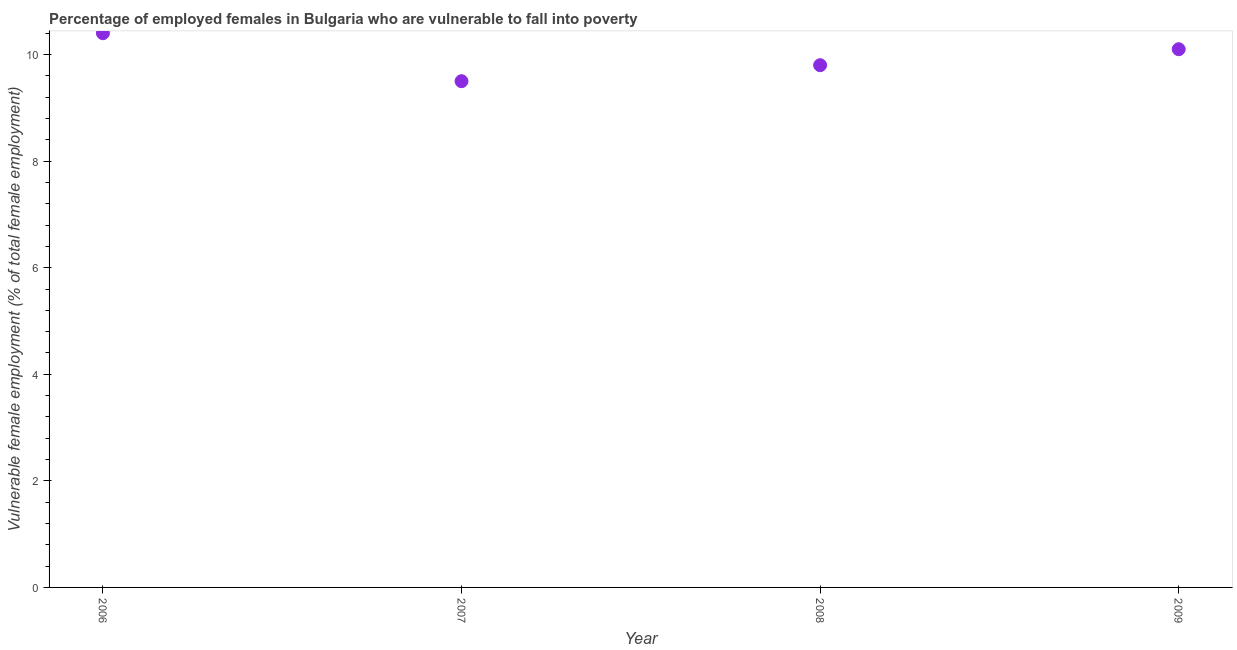What is the percentage of employed females who are vulnerable to fall into poverty in 2006?
Ensure brevity in your answer.  10.4. Across all years, what is the maximum percentage of employed females who are vulnerable to fall into poverty?
Your response must be concise. 10.4. Across all years, what is the minimum percentage of employed females who are vulnerable to fall into poverty?
Give a very brief answer. 9.5. In which year was the percentage of employed females who are vulnerable to fall into poverty minimum?
Provide a succinct answer. 2007. What is the sum of the percentage of employed females who are vulnerable to fall into poverty?
Your response must be concise. 39.8. What is the difference between the percentage of employed females who are vulnerable to fall into poverty in 2007 and 2008?
Ensure brevity in your answer.  -0.3. What is the average percentage of employed females who are vulnerable to fall into poverty per year?
Provide a short and direct response. 9.95. What is the median percentage of employed females who are vulnerable to fall into poverty?
Give a very brief answer. 9.95. In how many years, is the percentage of employed females who are vulnerable to fall into poverty greater than 0.8 %?
Ensure brevity in your answer.  4. Do a majority of the years between 2009 and 2007 (inclusive) have percentage of employed females who are vulnerable to fall into poverty greater than 8 %?
Give a very brief answer. No. What is the ratio of the percentage of employed females who are vulnerable to fall into poverty in 2006 to that in 2008?
Ensure brevity in your answer.  1.06. Is the difference between the percentage of employed females who are vulnerable to fall into poverty in 2006 and 2009 greater than the difference between any two years?
Your answer should be very brief. No. What is the difference between the highest and the second highest percentage of employed females who are vulnerable to fall into poverty?
Your answer should be very brief. 0.3. Is the sum of the percentage of employed females who are vulnerable to fall into poverty in 2007 and 2009 greater than the maximum percentage of employed females who are vulnerable to fall into poverty across all years?
Your answer should be compact. Yes. What is the difference between the highest and the lowest percentage of employed females who are vulnerable to fall into poverty?
Keep it short and to the point. 0.9. How many dotlines are there?
Your response must be concise. 1. How many years are there in the graph?
Your answer should be compact. 4. Are the values on the major ticks of Y-axis written in scientific E-notation?
Provide a succinct answer. No. What is the title of the graph?
Offer a terse response. Percentage of employed females in Bulgaria who are vulnerable to fall into poverty. What is the label or title of the Y-axis?
Give a very brief answer. Vulnerable female employment (% of total female employment). What is the Vulnerable female employment (% of total female employment) in 2006?
Keep it short and to the point. 10.4. What is the Vulnerable female employment (% of total female employment) in 2008?
Your answer should be compact. 9.8. What is the Vulnerable female employment (% of total female employment) in 2009?
Keep it short and to the point. 10.1. What is the difference between the Vulnerable female employment (% of total female employment) in 2006 and 2008?
Give a very brief answer. 0.6. What is the difference between the Vulnerable female employment (% of total female employment) in 2006 and 2009?
Ensure brevity in your answer.  0.3. What is the difference between the Vulnerable female employment (% of total female employment) in 2007 and 2008?
Offer a terse response. -0.3. What is the difference between the Vulnerable female employment (% of total female employment) in 2008 and 2009?
Make the answer very short. -0.3. What is the ratio of the Vulnerable female employment (% of total female employment) in 2006 to that in 2007?
Your answer should be very brief. 1.09. What is the ratio of the Vulnerable female employment (% of total female employment) in 2006 to that in 2008?
Keep it short and to the point. 1.06. What is the ratio of the Vulnerable female employment (% of total female employment) in 2006 to that in 2009?
Your response must be concise. 1.03. What is the ratio of the Vulnerable female employment (% of total female employment) in 2007 to that in 2009?
Ensure brevity in your answer.  0.94. 